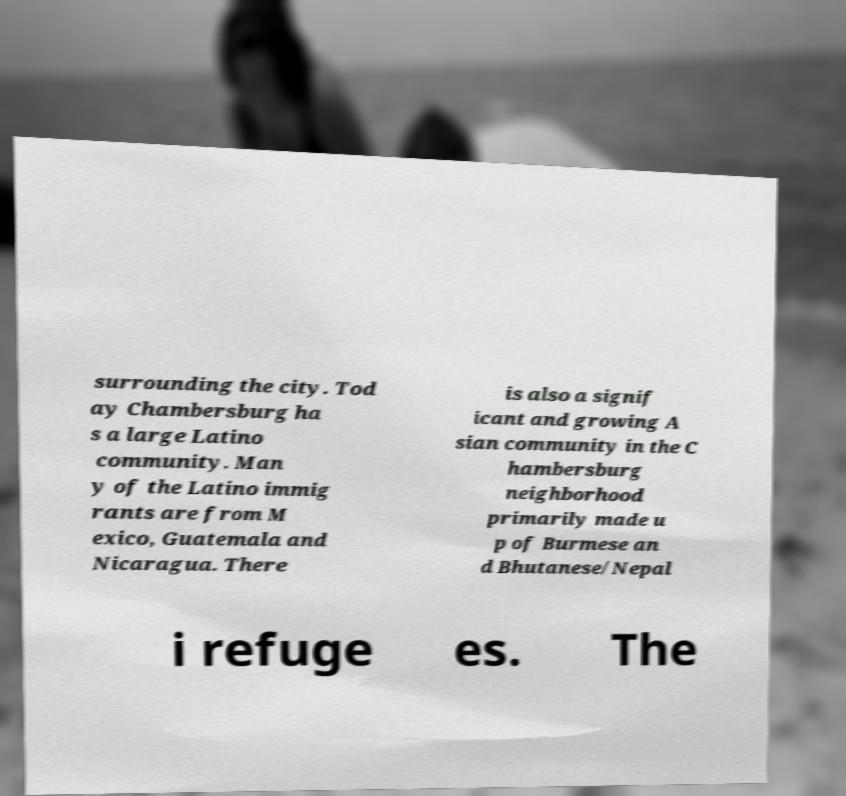Please read and relay the text visible in this image. What does it say? surrounding the city. Tod ay Chambersburg ha s a large Latino community. Man y of the Latino immig rants are from M exico, Guatemala and Nicaragua. There is also a signif icant and growing A sian community in the C hambersburg neighborhood primarily made u p of Burmese an d Bhutanese/Nepal i refuge es. The 